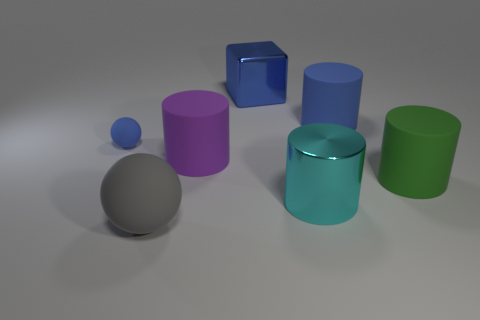Add 1 big purple rubber objects. How many objects exist? 8 Subtract all spheres. How many objects are left? 5 Add 5 large blue cylinders. How many large blue cylinders are left? 6 Add 7 large green cubes. How many large green cubes exist? 7 Subtract 0 brown spheres. How many objects are left? 7 Subtract all small spheres. Subtract all blue things. How many objects are left? 3 